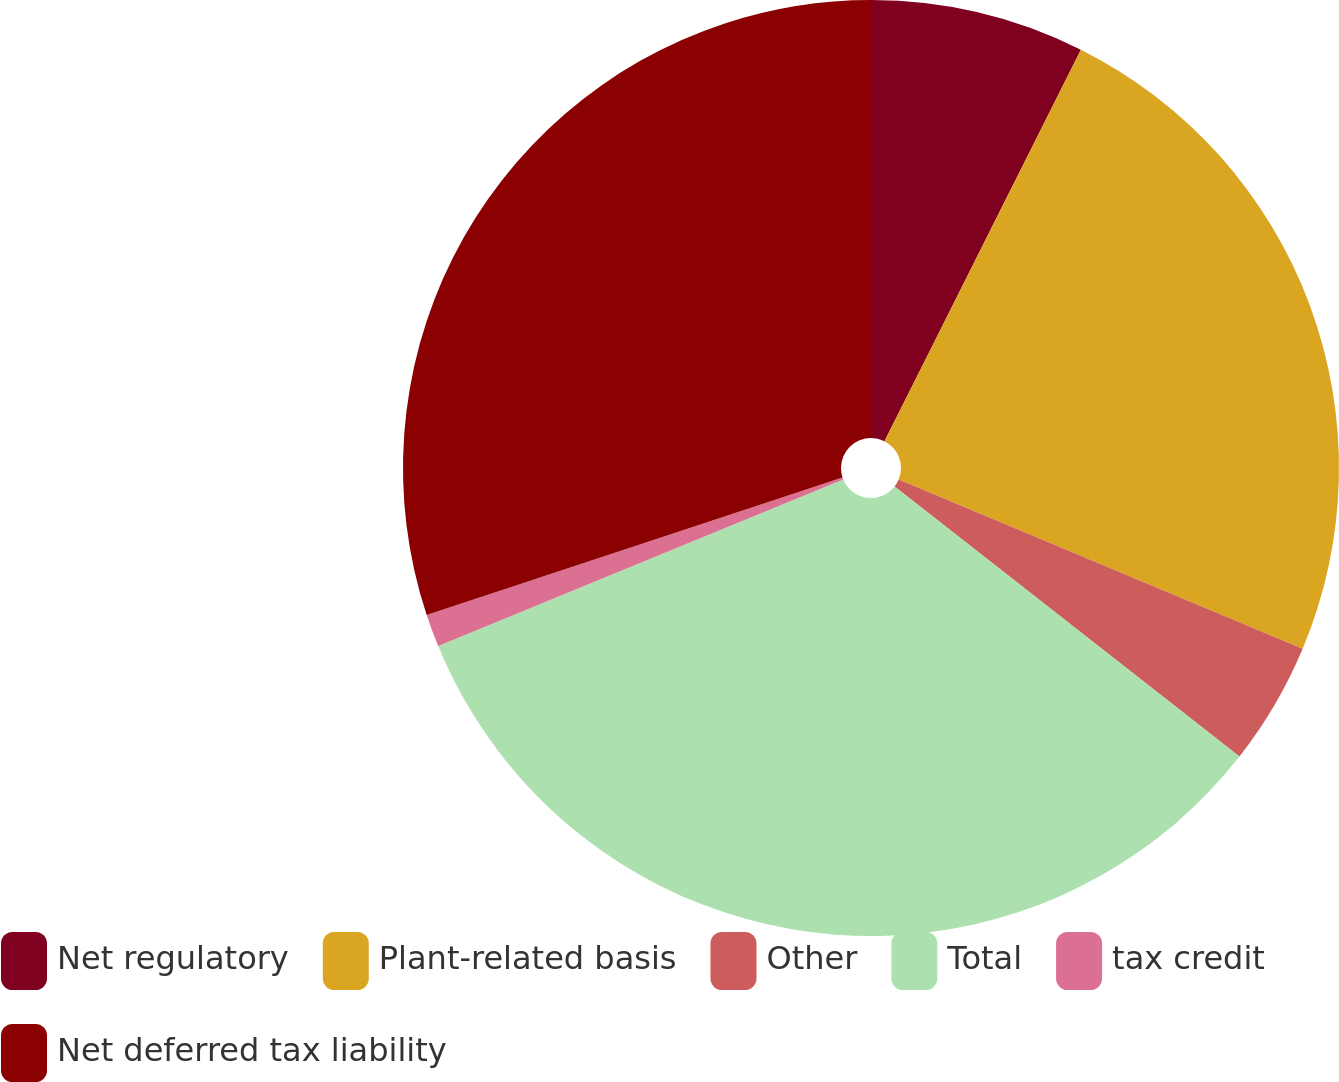<chart> <loc_0><loc_0><loc_500><loc_500><pie_chart><fcel>Net regulatory<fcel>Plant-related basis<fcel>Other<fcel>Total<fcel>tax credit<fcel>Net deferred tax liability<nl><fcel>7.4%<fcel>23.91%<fcel>4.26%<fcel>33.21%<fcel>1.13%<fcel>30.08%<nl></chart> 